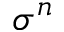Convert formula to latex. <formula><loc_0><loc_0><loc_500><loc_500>\sigma ^ { n }</formula> 